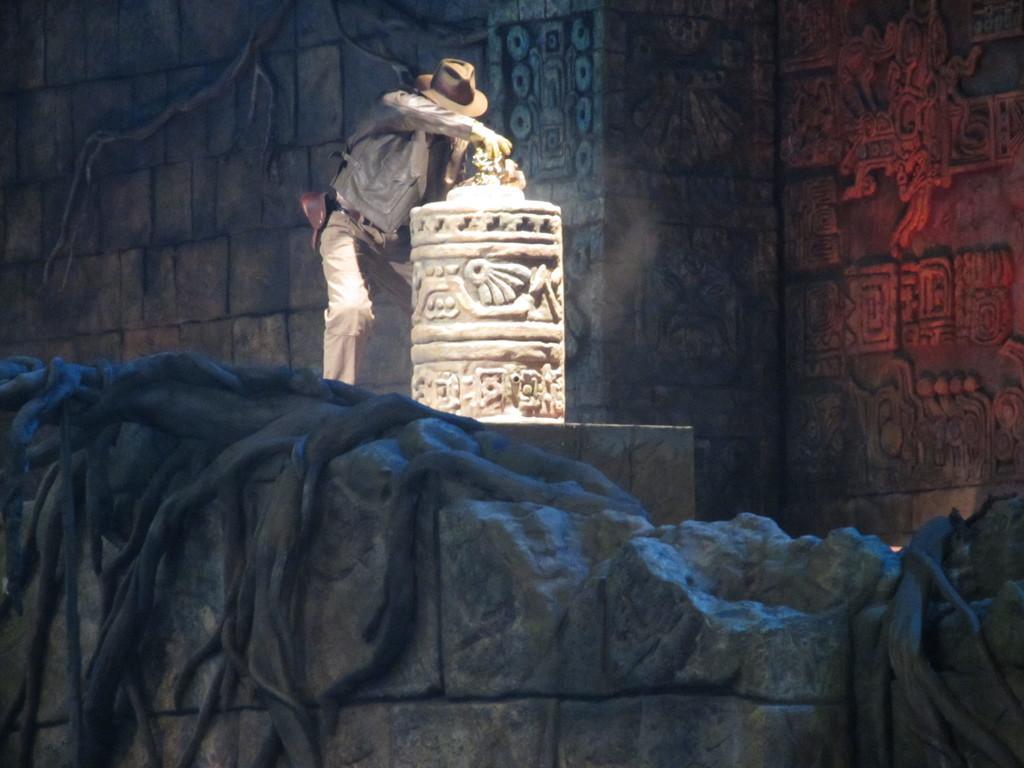Please provide a concise description of this image. In this image we can see a person standing and also we can see an object, which looks like a sculpture, in the background we can see the wall. 